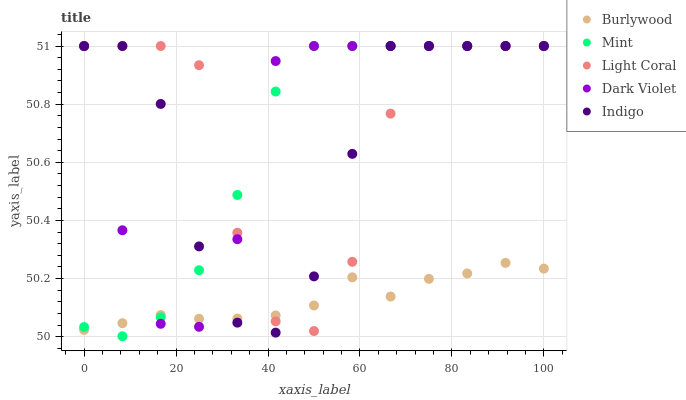Does Burlywood have the minimum area under the curve?
Answer yes or no. Yes. Does Dark Violet have the maximum area under the curve?
Answer yes or no. Yes. Does Light Coral have the minimum area under the curve?
Answer yes or no. No. Does Light Coral have the maximum area under the curve?
Answer yes or no. No. Is Burlywood the smoothest?
Answer yes or no. Yes. Is Light Coral the roughest?
Answer yes or no. Yes. Is Mint the smoothest?
Answer yes or no. No. Is Mint the roughest?
Answer yes or no. No. Does Mint have the lowest value?
Answer yes or no. Yes. Does Light Coral have the lowest value?
Answer yes or no. No. Does Indigo have the highest value?
Answer yes or no. Yes. Does Light Coral intersect Indigo?
Answer yes or no. Yes. Is Light Coral less than Indigo?
Answer yes or no. No. Is Light Coral greater than Indigo?
Answer yes or no. No. 